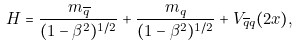Convert formula to latex. <formula><loc_0><loc_0><loc_500><loc_500>H = \frac { m _ { \overline { q } } } { ( 1 - \beta ^ { 2 } ) ^ { 1 / 2 } } + \frac { m _ { q } } { ( 1 - \beta ^ { 2 } ) ^ { 1 / 2 } } + V _ { \overline { q } q } ( 2 x ) ,</formula> 